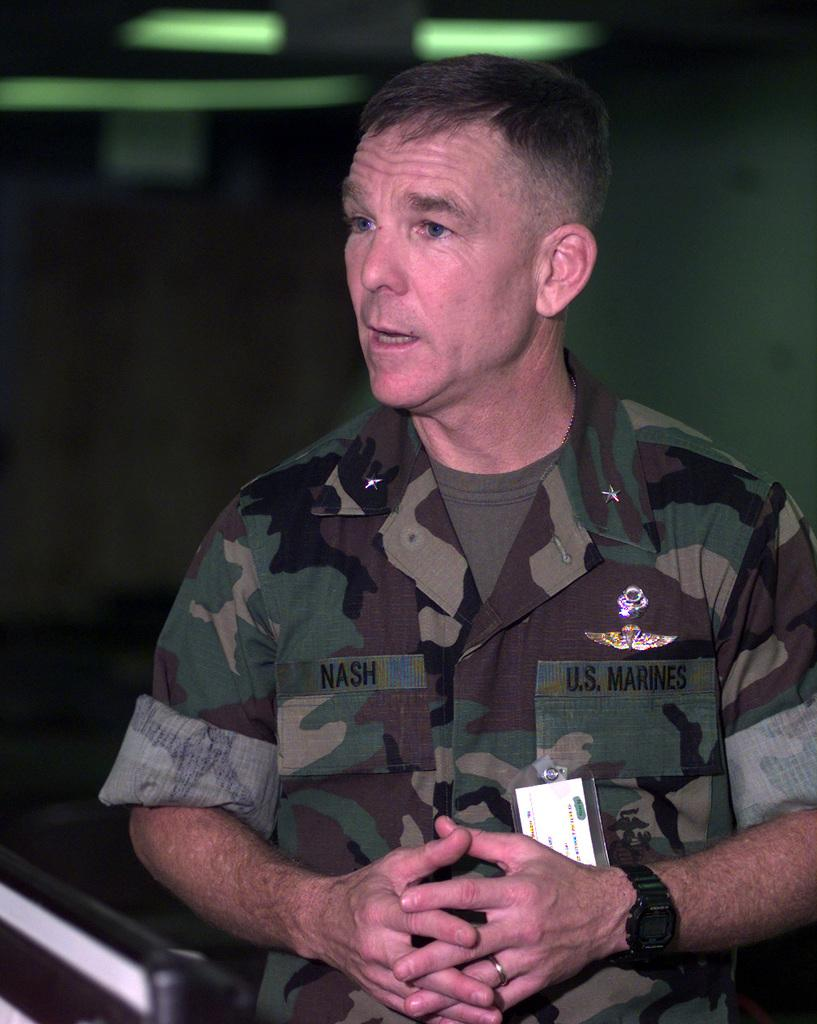What is the main subject of the image? There is a man in the image. What type of jar is the fireman holding in the image? There is no fireman or jar present in the image; it only features a man. 